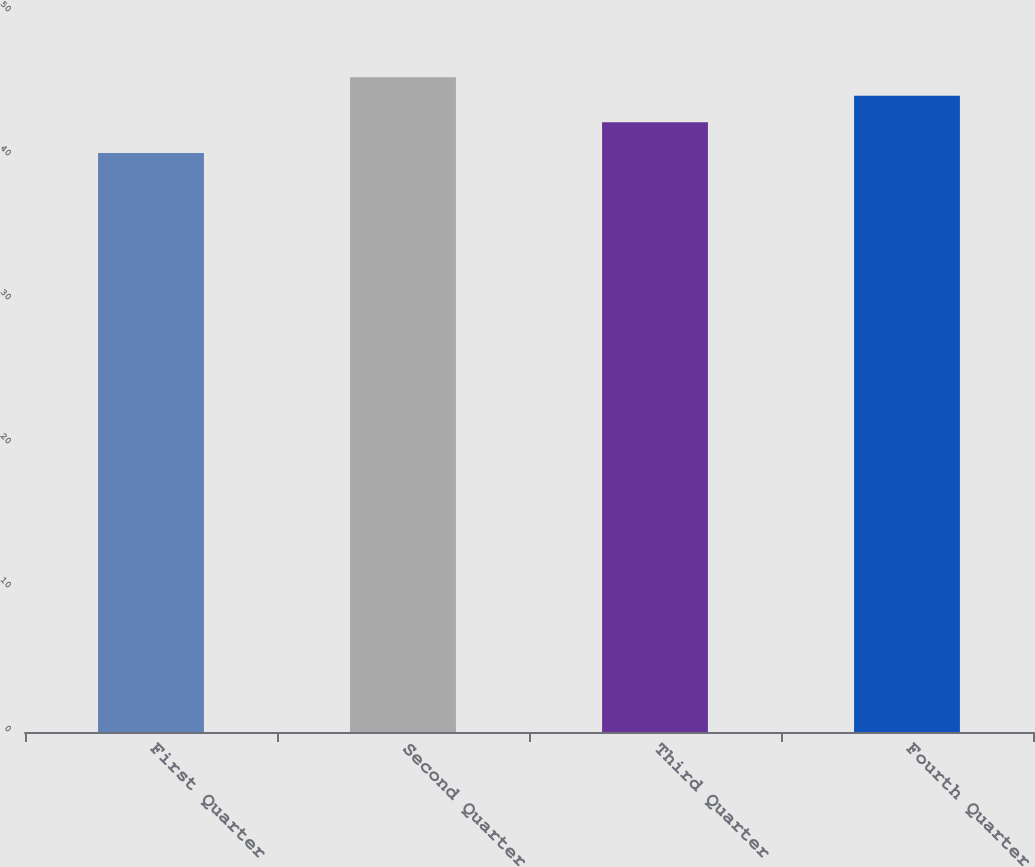<chart> <loc_0><loc_0><loc_500><loc_500><bar_chart><fcel>First Quarter<fcel>Second Quarter<fcel>Third Quarter<fcel>Fourth Quarter<nl><fcel>40.21<fcel>45.47<fcel>42.35<fcel>44.18<nl></chart> 